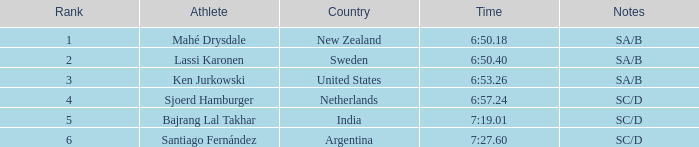40? 2.0. I'm looking to parse the entire table for insights. Could you assist me with that? {'header': ['Rank', 'Athlete', 'Country', 'Time', 'Notes'], 'rows': [['1', 'Mahé Drysdale', 'New Zealand', '6:50.18', 'SA/B'], ['2', 'Lassi Karonen', 'Sweden', '6:50.40', 'SA/B'], ['3', 'Ken Jurkowski', 'United States', '6:53.26', 'SA/B'], ['4', 'Sjoerd Hamburger', 'Netherlands', '6:57.24', 'SC/D'], ['5', 'Bajrang Lal Takhar', 'India', '7:19.01', 'SC/D'], ['6', 'Santiago Fernández', 'Argentina', '7:27.60', 'SC/D']]} 